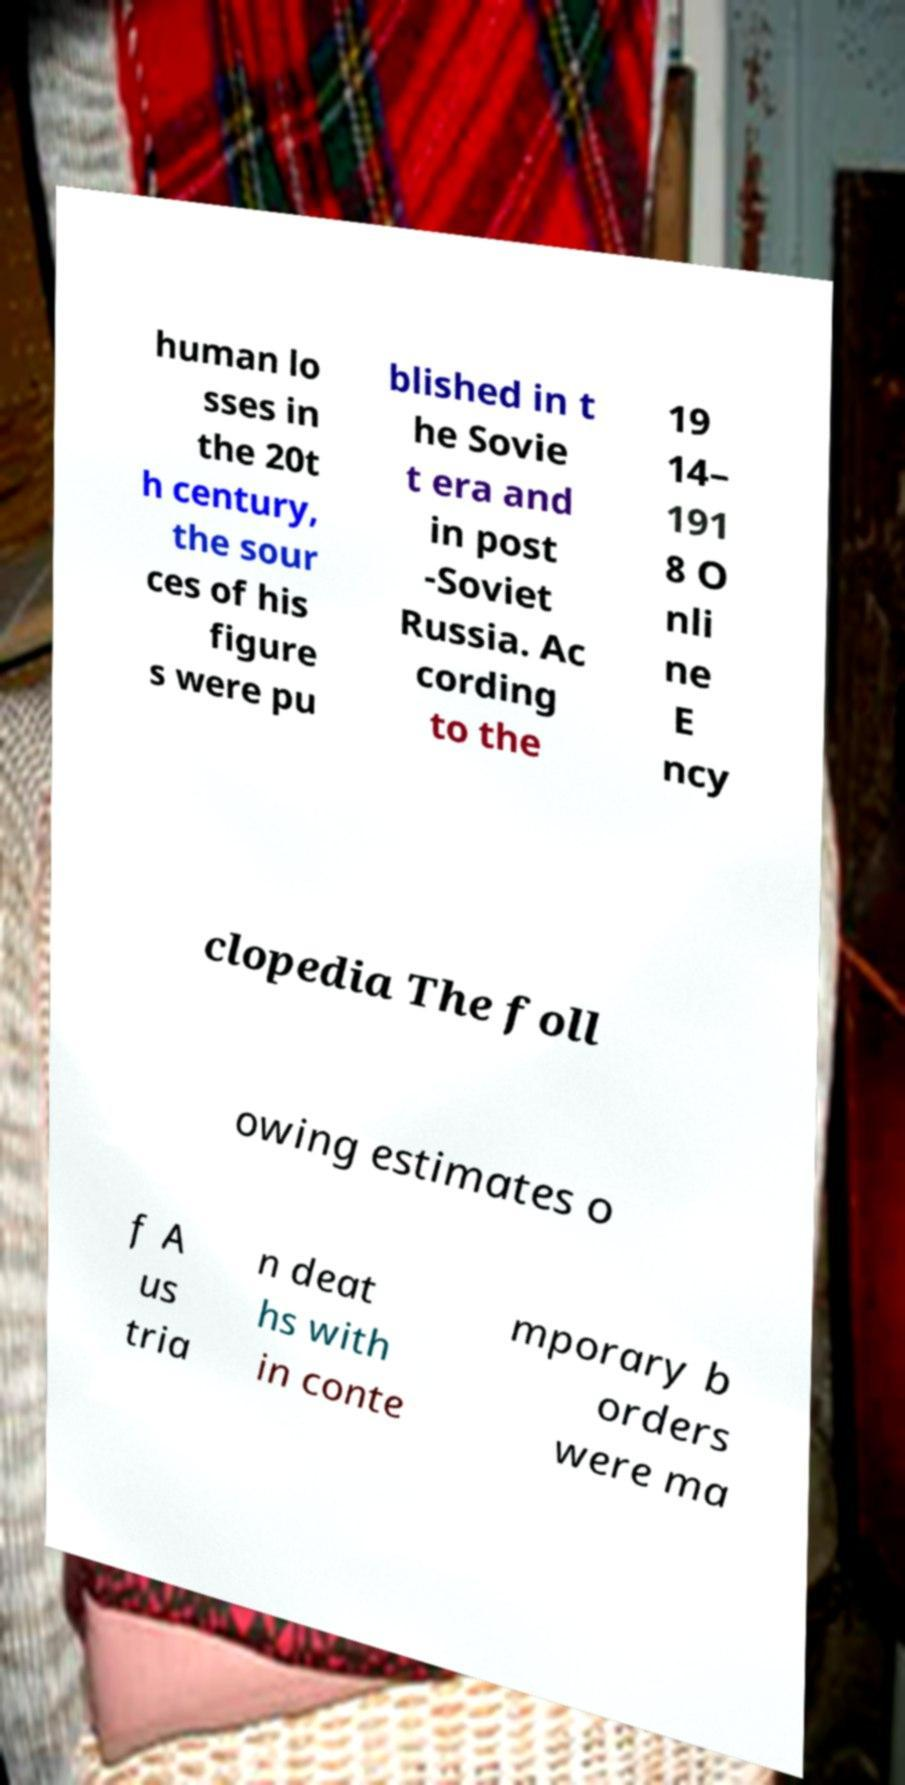Please identify and transcribe the text found in this image. human lo sses in the 20t h century, the sour ces of his figure s were pu blished in t he Sovie t era and in post -Soviet Russia. Ac cording to the 19 14– 191 8 O nli ne E ncy clopedia The foll owing estimates o f A us tria n deat hs with in conte mporary b orders were ma 